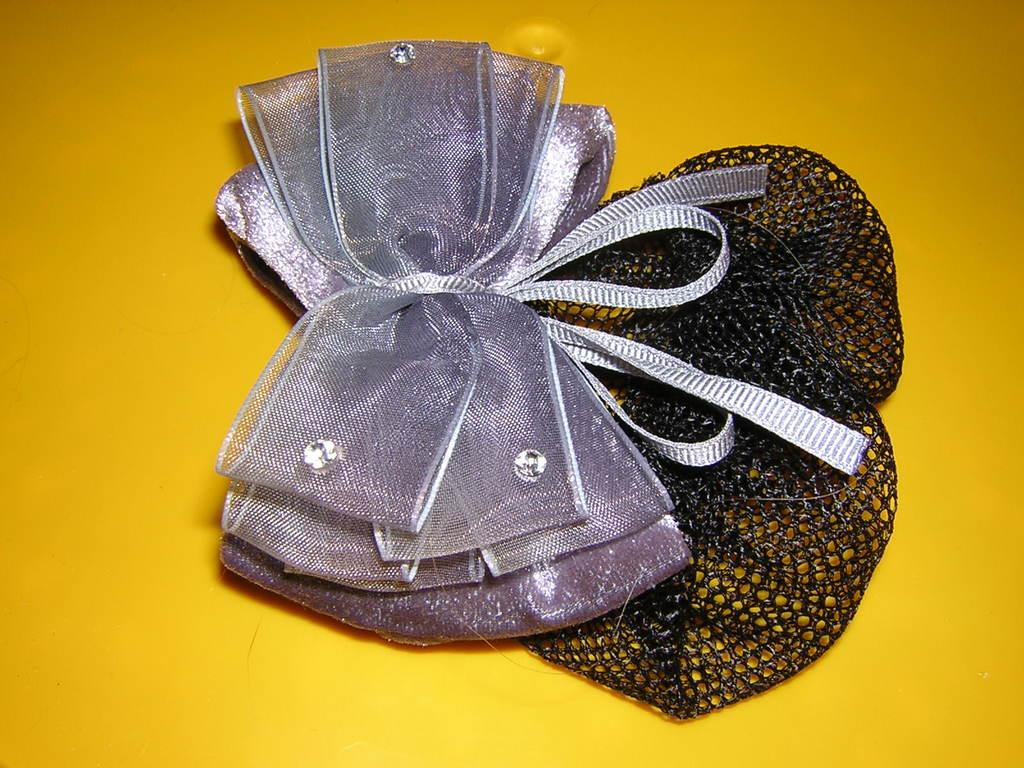What type of accessory is present in the image? There is a head wear in the image. What additional detail can be seen on the head wear? There are ribbons in the image. What color is the background of the image? The background of the image is yellow. Can you see any bears in the image? No, there are no bears present in the image. What type of vein is visible in the image? There is no vein visible in the image; it features a head wear with ribbons against a yellow background. 